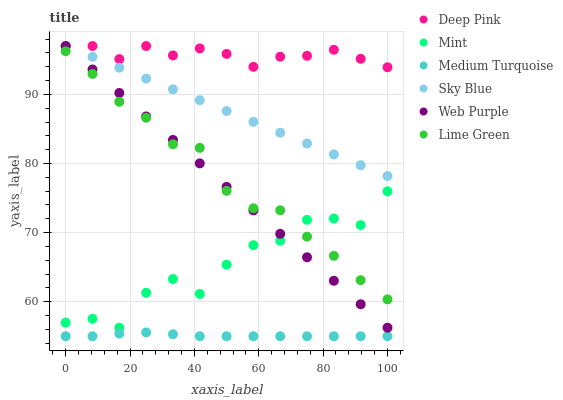Does Medium Turquoise have the minimum area under the curve?
Answer yes or no. Yes. Does Deep Pink have the maximum area under the curve?
Answer yes or no. Yes. Does Mint have the minimum area under the curve?
Answer yes or no. No. Does Mint have the maximum area under the curve?
Answer yes or no. No. Is Sky Blue the smoothest?
Answer yes or no. Yes. Is Mint the roughest?
Answer yes or no. Yes. Is Web Purple the smoothest?
Answer yes or no. No. Is Web Purple the roughest?
Answer yes or no. No. Does Medium Turquoise have the lowest value?
Answer yes or no. Yes. Does Mint have the lowest value?
Answer yes or no. No. Does Sky Blue have the highest value?
Answer yes or no. Yes. Does Mint have the highest value?
Answer yes or no. No. Is Medium Turquoise less than Lime Green?
Answer yes or no. Yes. Is Sky Blue greater than Mint?
Answer yes or no. Yes. Does Lime Green intersect Web Purple?
Answer yes or no. Yes. Is Lime Green less than Web Purple?
Answer yes or no. No. Is Lime Green greater than Web Purple?
Answer yes or no. No. Does Medium Turquoise intersect Lime Green?
Answer yes or no. No. 